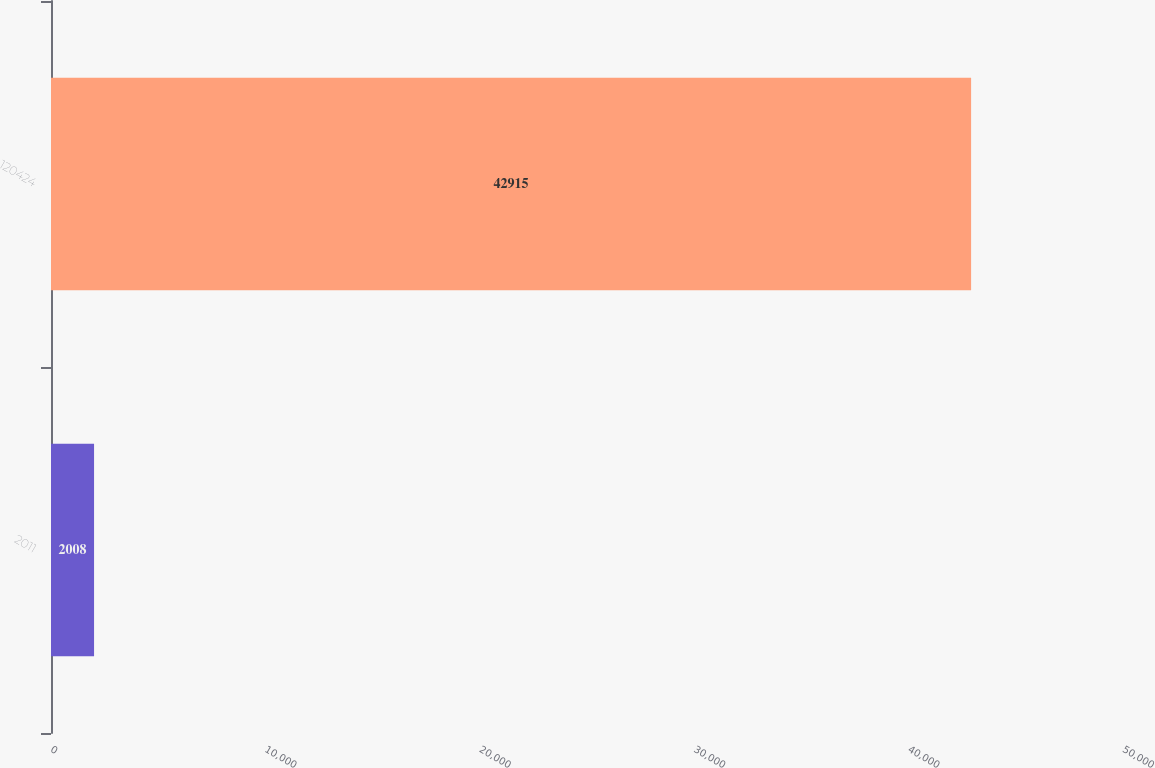<chart> <loc_0><loc_0><loc_500><loc_500><bar_chart><fcel>2011<fcel>120424<nl><fcel>2008<fcel>42915<nl></chart> 